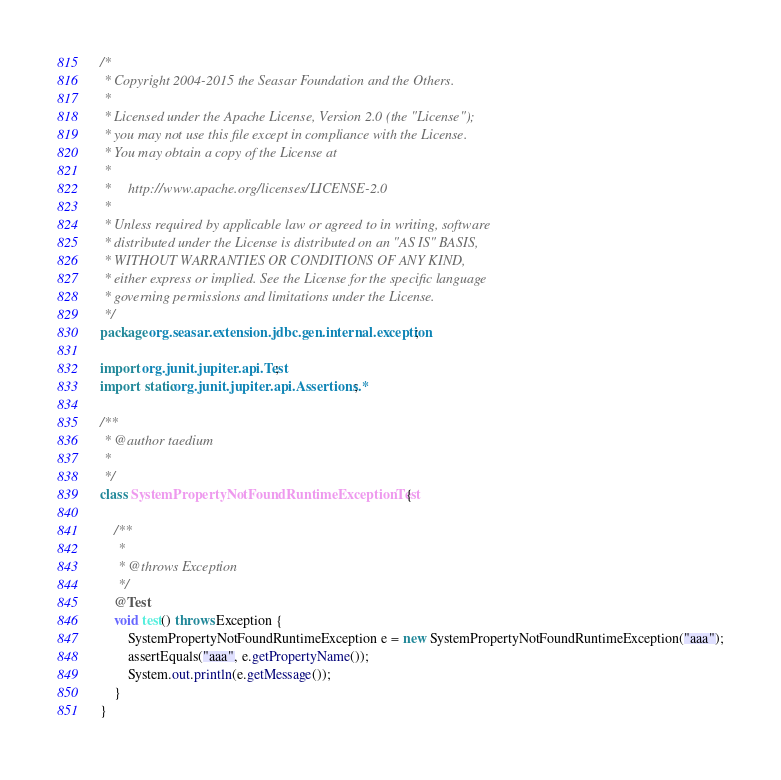Convert code to text. <code><loc_0><loc_0><loc_500><loc_500><_Java_>/*
 * Copyright 2004-2015 the Seasar Foundation and the Others.
 *
 * Licensed under the Apache License, Version 2.0 (the "License");
 * you may not use this file except in compliance with the License.
 * You may obtain a copy of the License at
 *
 *     http://www.apache.org/licenses/LICENSE-2.0
 *
 * Unless required by applicable law or agreed to in writing, software
 * distributed under the License is distributed on an "AS IS" BASIS,
 * WITHOUT WARRANTIES OR CONDITIONS OF ANY KIND,
 * either express or implied. See the License for the specific language
 * governing permissions and limitations under the License.
 */
package org.seasar.extension.jdbc.gen.internal.exception;

import org.junit.jupiter.api.Test;
import static org.junit.jupiter.api.Assertions.*;

/**
 * @author taedium
 * 
 */
class SystemPropertyNotFoundRuntimeExceptionTest {

    /**
     * 
     * @throws Exception
     */
    @Test
    void test() throws Exception {
        SystemPropertyNotFoundRuntimeException e = new SystemPropertyNotFoundRuntimeException("aaa");
        assertEquals("aaa", e.getPropertyName());
        System.out.println(e.getMessage());
    }
}
</code> 